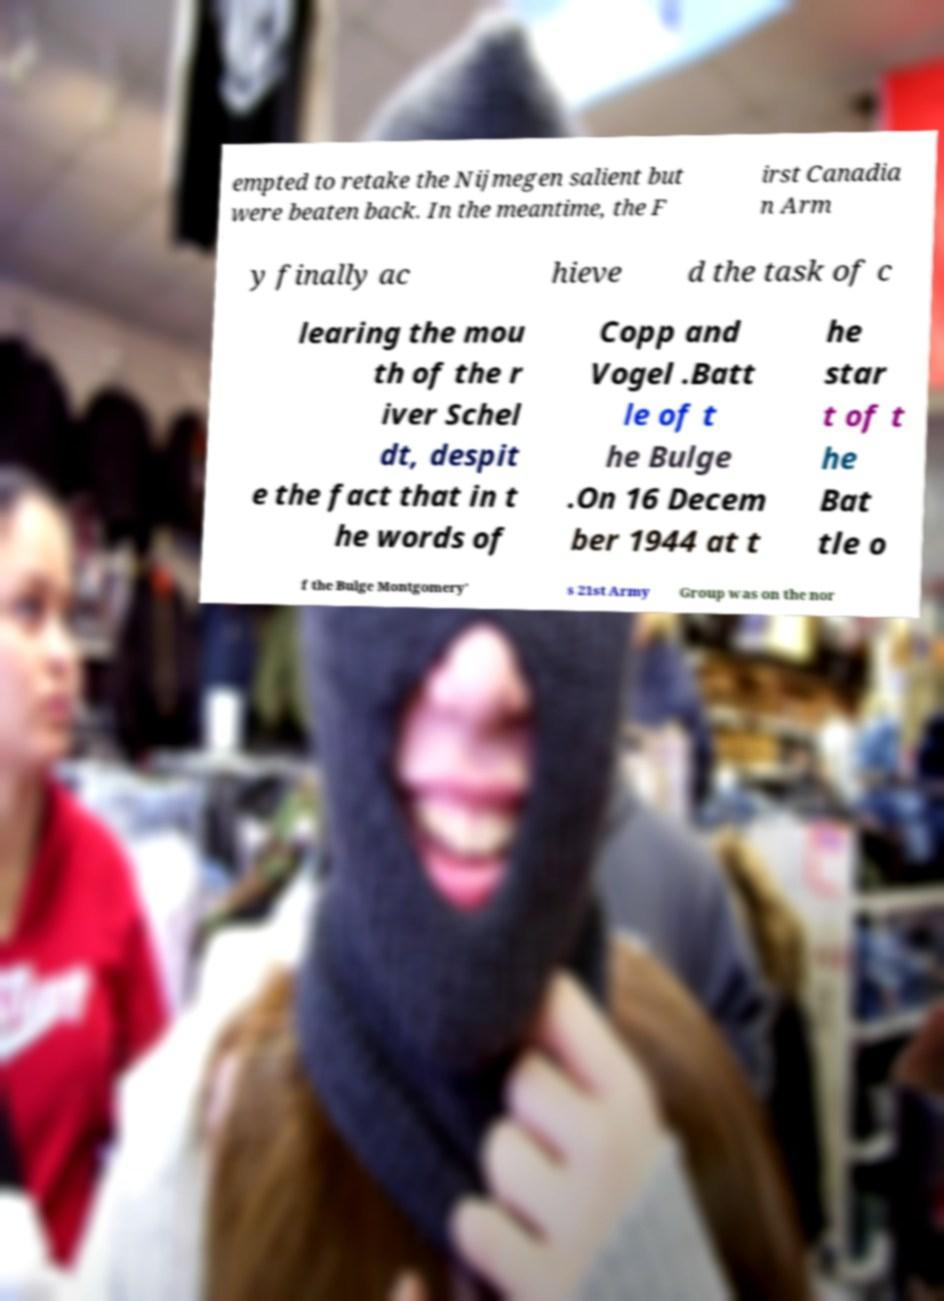There's text embedded in this image that I need extracted. Can you transcribe it verbatim? empted to retake the Nijmegen salient but were beaten back. In the meantime, the F irst Canadia n Arm y finally ac hieve d the task of c learing the mou th of the r iver Schel dt, despit e the fact that in t he words of Copp and Vogel .Batt le of t he Bulge .On 16 Decem ber 1944 at t he star t of t he Bat tle o f the Bulge Montgomery' s 21st Army Group was on the nor 